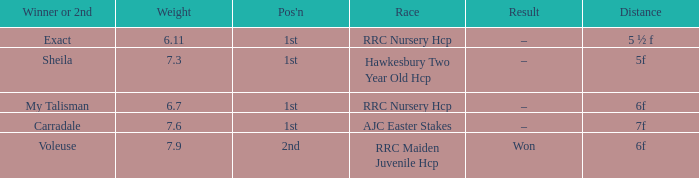What was the distance when the weight was 6.11? 5 ½ f. 